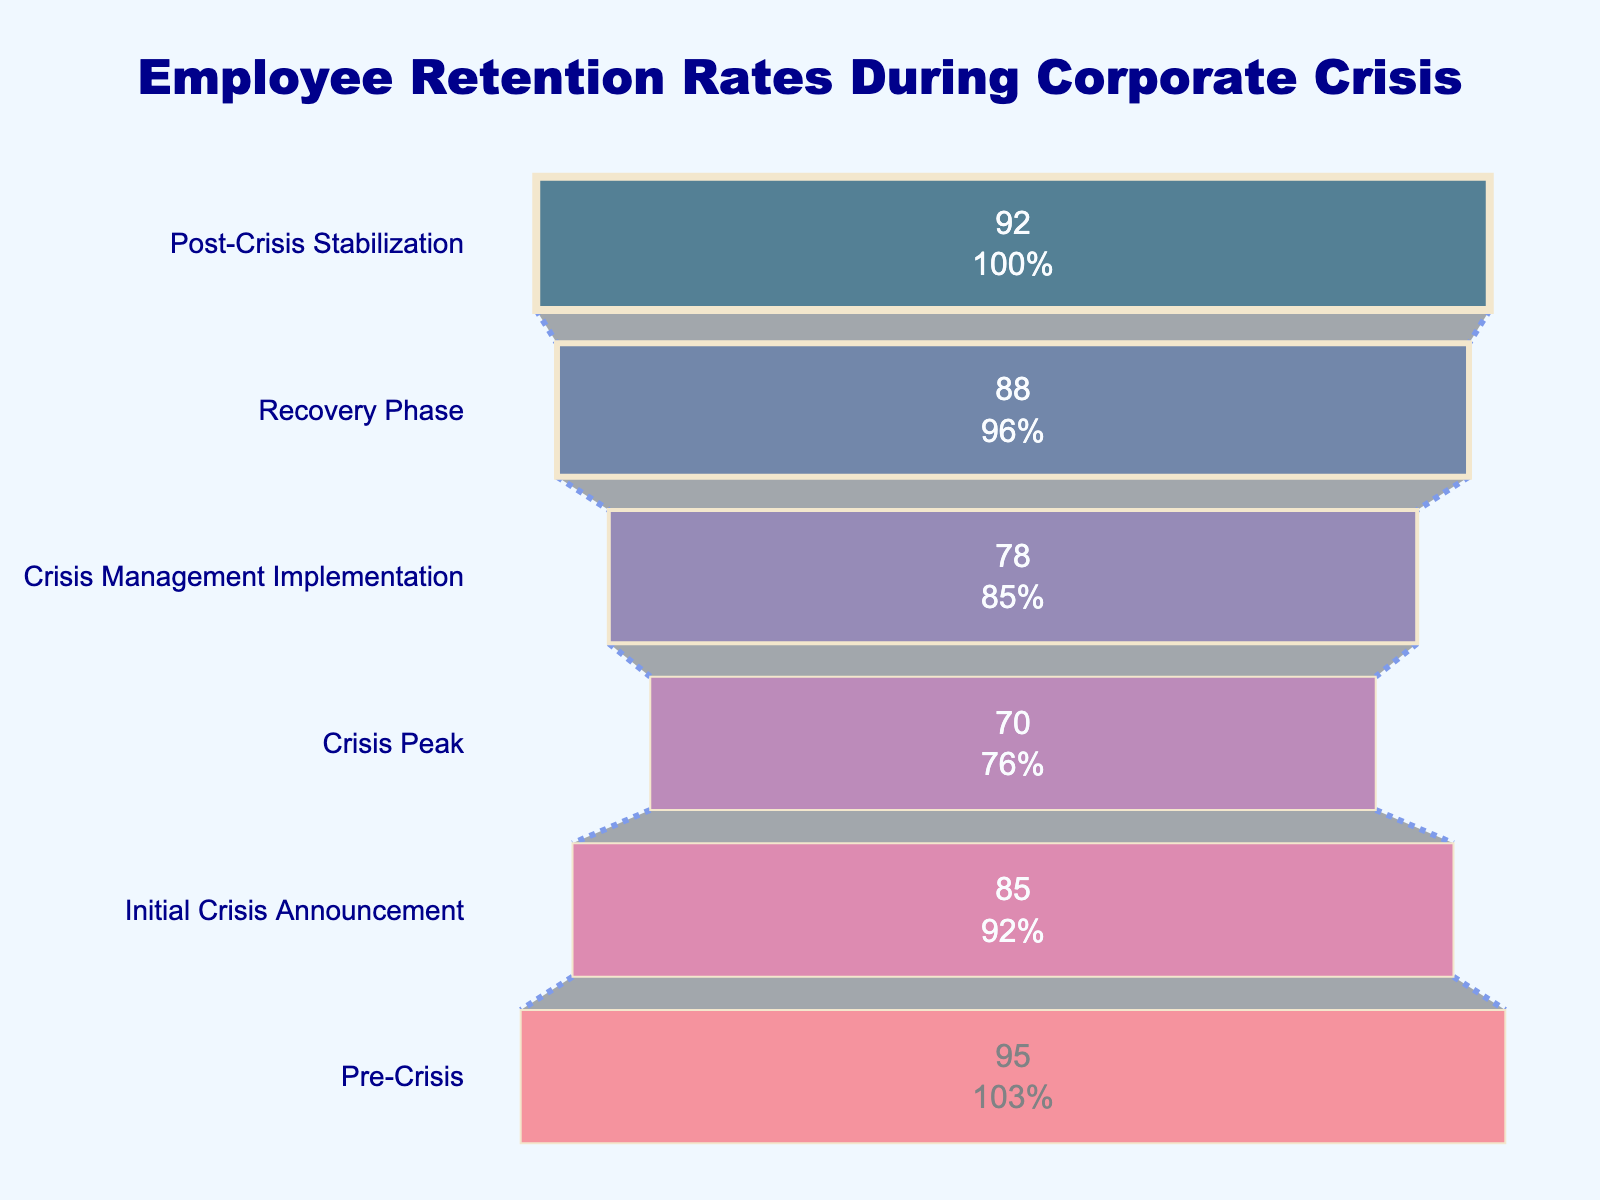What is the title of the funnel chart? The title of the chart can be found at the top of the figure. It is the main text that explains what the chart is about. In this case, it is "Employee Retention Rates During Corporate Crisis".
Answer: Employee Retention Rates During Corporate Crisis How many stages are displayed in the funnel chart? Count the number of distinct stages listed on the y-axis of the funnel chart. Each stage represents a different phase of the corporate crisis.
Answer: Six Which stage has the lowest retention rate? Look at each stage's retention rate values and identify the smallest. The lowest retention rate is observed at the stage with the smallest value.
Answer: Crisis Peak What is the difference in retention rates between the Initial Crisis Announcement and the Crisis Peak? Subtract the retention rate of the Crisis Peak stage from the retention rate of the Initial Crisis Announcement stage: 85 - 70.
Answer: 15 Which stage shows the greatest increase in retention rate compared to the previous stage? Compare the retention rate values of consecutive stages to identify where the biggest increase occurs.
Answer: Crisis Management Implementation (from Crisis Peak) Calculate the average retention rate across all stages. Sum the retention rates of all stages and divide by the number of stages: (95 + 85 + 70 + 78 + 88 + 92) / 6.
Answer: 84.67 What percentage of the initial pre-crisis employees remained by the Recovery Phase? The retention rate at the Recovery Phase indicates the percentage of initial employees remaining. This value is given directly in the chart.
Answer: 88% In which stage does the retention rate increase after initially declining? Identify the stages where the retention rate decreases and then increases again by examining the values from one stage to the next.
Answer: From Crisis Peak to Crisis Management Implementation Compare the retention rate at the Recovery Phase to the Post-Crisis Stabilization phase. Which is higher and by how much? Subtract the retention rate of the Recovery Phase stage from the Post-Crisis Stabilization stage to find the difference: 92 - 88.
Answer: Post-Crisis Stabilization is higher by 4 What is the color of the segment representing the Post-Crisis Stabilization stage? Look at the color code defined for each stage and find the color corresponding to the Post-Crisis Stabilization stage.
Answer: Red-ish (#f95d6a) 